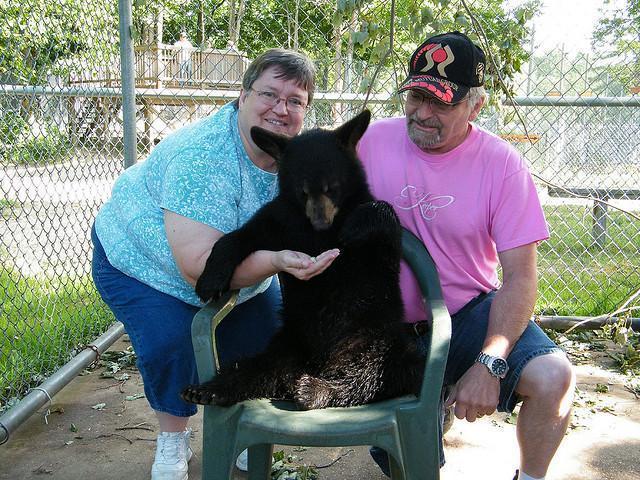How many people are in the picture?
Give a very brief answer. 2. 